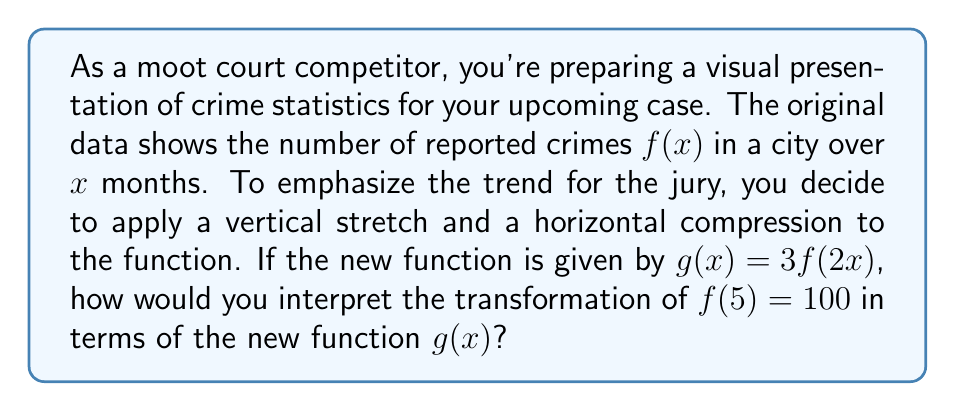Give your solution to this math problem. Let's approach this step-by-step:

1) The original function $f(x)$ represents the number of reported crimes over $x$ months.

2) We're given that $f(5) = 100$, meaning that after 5 months, there were 100 reported crimes.

3) The new function $g(x) = 3f(2x)$ involves two transformations:
   a) A vertical stretch by a factor of 3
   b) A horizontal compression by a factor of 2

4) To find the corresponding point on $g(x)$, we need to:
   a) First, apply the horizontal compression: $2x = 5$
      Solving for $x$: $x = \frac{5}{2} = 2.5$
   b) Then, apply the vertical stretch: $g(2.5) = 3f(5) = 3(100) = 300$

5) Interpreting this transformation:
   - The horizontal compression means that the same number of crimes now occurs in half the time.
   - The vertical stretch triples the number of reported crimes at each point.

6) Therefore, in the new function $g(x)$:
   - The 100 crimes originally reported at 5 months are now represented as 300 crimes at 2.5 months.
Answer: In the transformed function $g(x)$, the point $(5, 100)$ from the original function $f(x)$ becomes $(2.5, 300)$. This means that in the scaled presentation, 300 crimes are shown to occur after 2.5 months, emphasizing a more rapid and severe crime rate for the jury. 